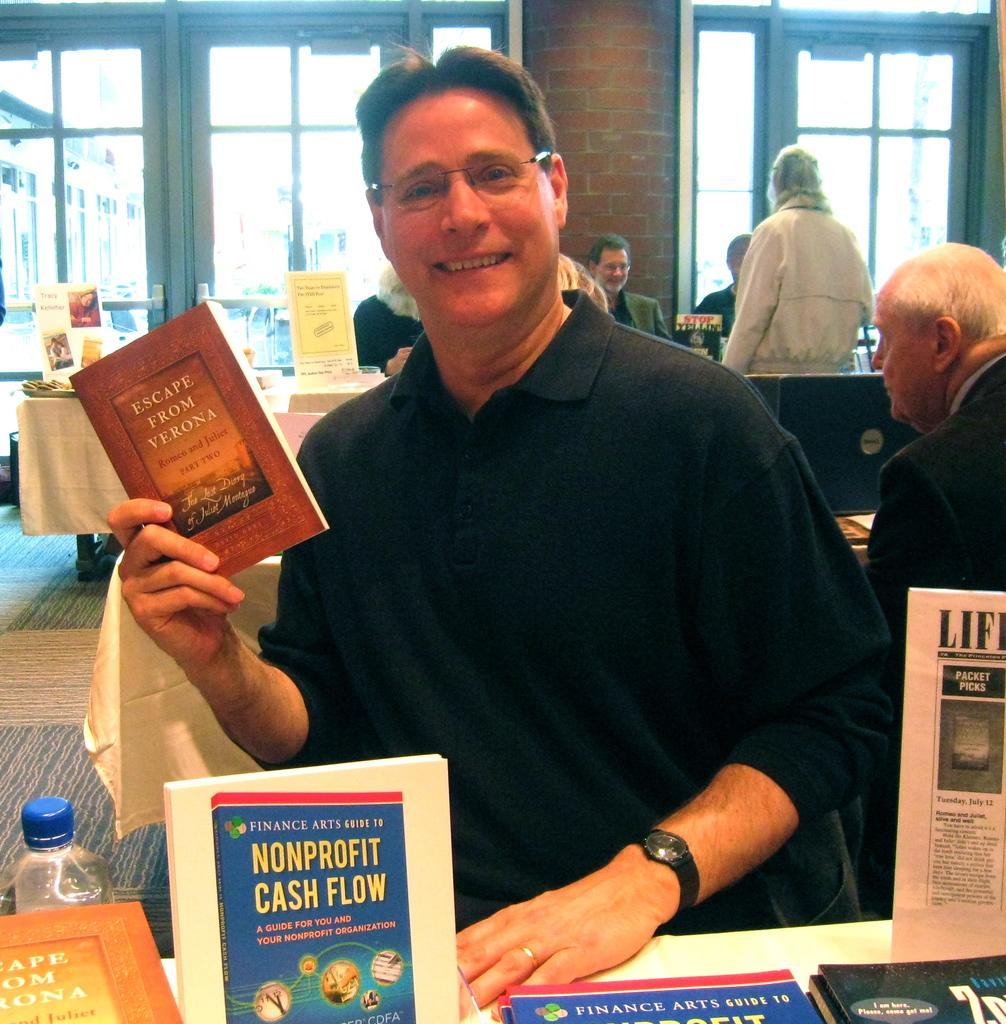<image>
Render a clear and concise summary of the photo. A book titled " Escape From Verona" Romeo and Juliet part two. 